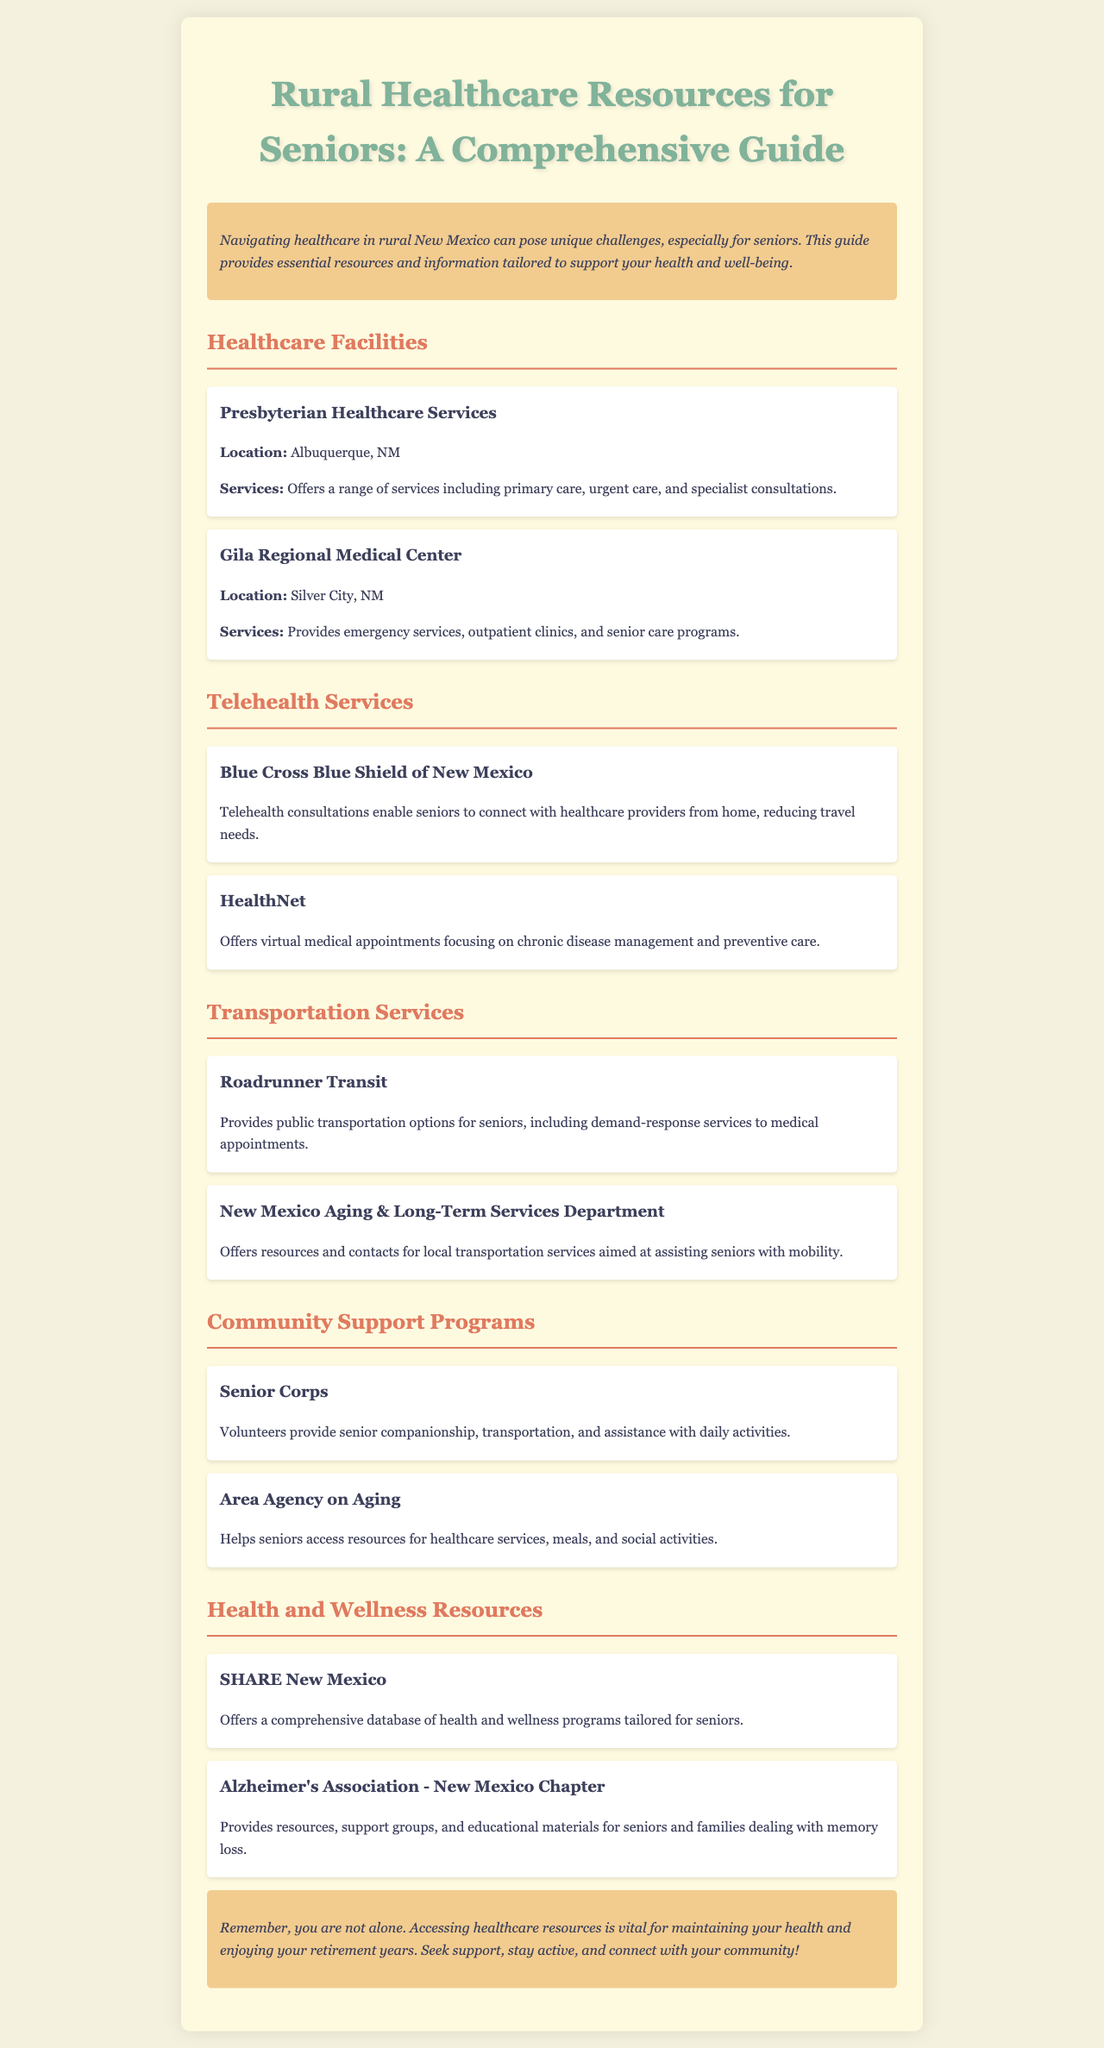What is the title of the brochure? The title of the brochure is presented prominently at the top and provides a clear indication of its focus.
Answer: Rural Healthcare Resources for Seniors: A Comprehensive Guide How many healthcare facilities are mentioned? The document lists two healthcare facilities in the section about Healthcare Facilities.
Answer: 2 What service does Gila Regional Medical Center provide? The document provides specific services offered by Gila Regional Medical Center, enhancing understanding of its role.
Answer: Emergency services Which organization offers telehealth consultations? The document specifies Blue Cross Blue Shield of New Mexico as a provider of telehealth consultations.
Answer: Blue Cross Blue Shield of New Mexico What assistance does Senior Corps provide? Senior Corps is described in the document as offering companionship and transportation, addressing seniors' needs.
Answer: Companionship What is one of the resources offered by SHARE New Mexico? The document indicates that SHARE New Mexico provides a specific type of resource tailored for seniors.
Answer: Database of health and wellness programs How does the Roadrunner Transit help seniors? Roadrunner Transit is explained in the document as providing a specific kind of service that aids seniors in transportation.
Answer: Public transportation What is a primary focus of the Alzheimer's Association - New Mexico Chapter? The document outlines the focus of the Alzheimer's Association in regard to the actions they take for seniors and families.
Answer: Support groups What can seniors access through the Area Agency on Aging? The document states that the Area Agency on Aging helps seniors access a specific type of resource beneficial for their needs.
Answer: Healthcare services 